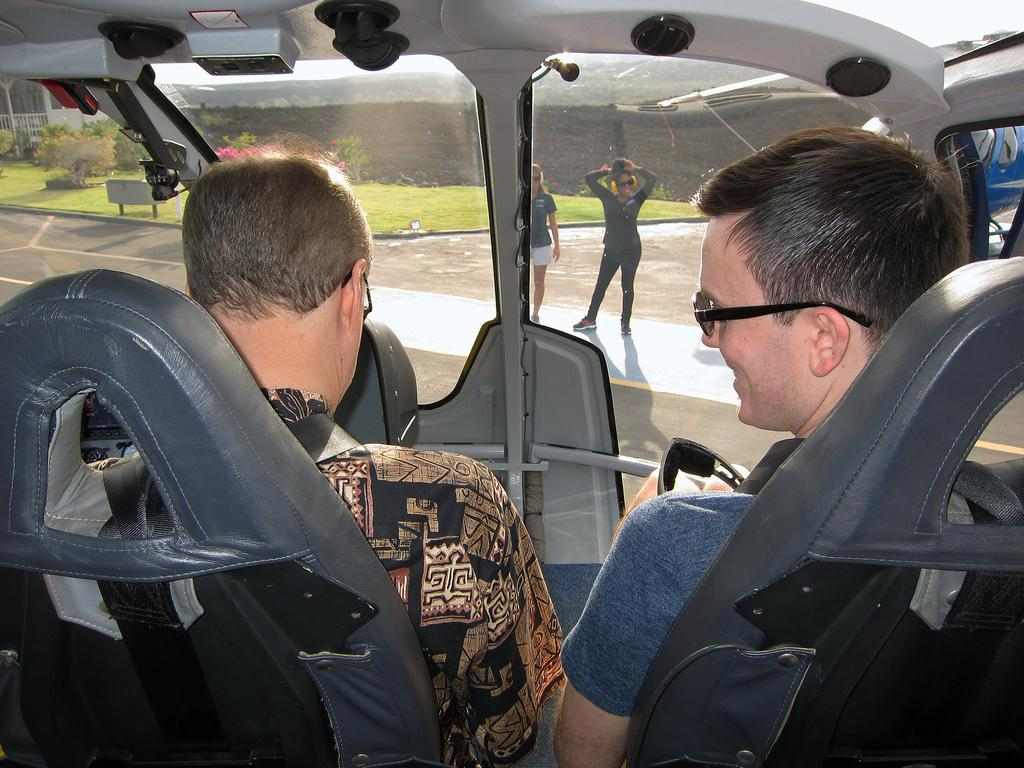How many people are inside the motor vehicle in the image? There are two persons sitting in a motor vehicle in the image. What is the woman in the image doing? The woman is standing on the road in the image. What can be seen on the ground in the image? The ground is visible in the image. What type of structures can be seen in the image? There are walls in the image. What type of vegetation is present in the image? Bushes are present in the image. What is visible in the sky in the image? The sky is visible in the image. What type of quill is the woman holding in the image? There is no quill present in the image; the woman is standing on the road. What type of reward is the motor vehicle receiving in the image? There is no reward being given to the motor vehicle in the image; it is simply parked with two people inside. 